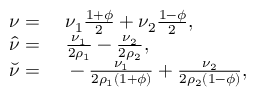<formula> <loc_0><loc_0><loc_500><loc_500>\begin{array} { r l } { \nu = } & \nu _ { 1 } \frac { 1 + \phi } { 2 } + \nu _ { 2 } \frac { 1 - \phi } { 2 } , } \\ { \hat { \nu } = } & \frac { \nu _ { 1 } } { 2 \rho _ { 1 } } - \frac { \nu _ { 2 } } { 2 \rho _ { 2 } } , } \\ { \breve { \nu } = } & - \frac { \nu _ { 1 } } { 2 \rho _ { 1 } ( 1 + \phi ) } + \frac { \nu _ { 2 } } { 2 \rho _ { 2 } ( 1 - \phi ) } , } \end{array}</formula> 